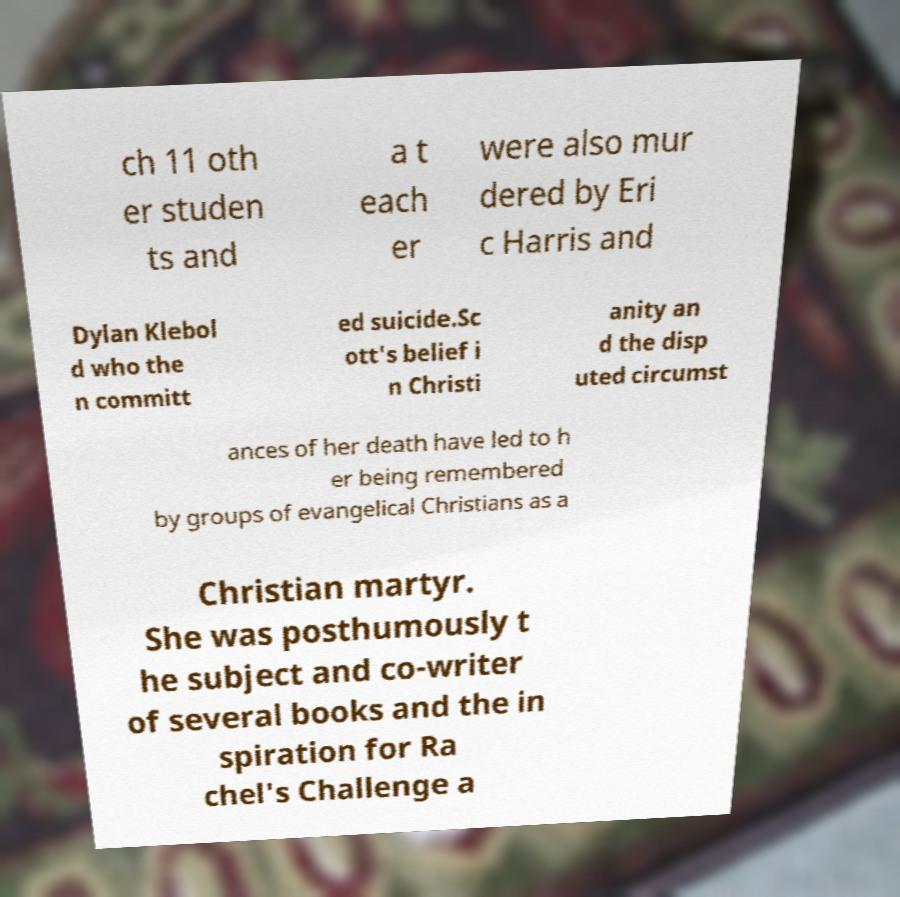There's text embedded in this image that I need extracted. Can you transcribe it verbatim? ch 11 oth er studen ts and a t each er were also mur dered by Eri c Harris and Dylan Klebol d who the n committ ed suicide.Sc ott's belief i n Christi anity an d the disp uted circumst ances of her death have led to h er being remembered by groups of evangelical Christians as a Christian martyr. She was posthumously t he subject and co-writer of several books and the in spiration for Ra chel's Challenge a 